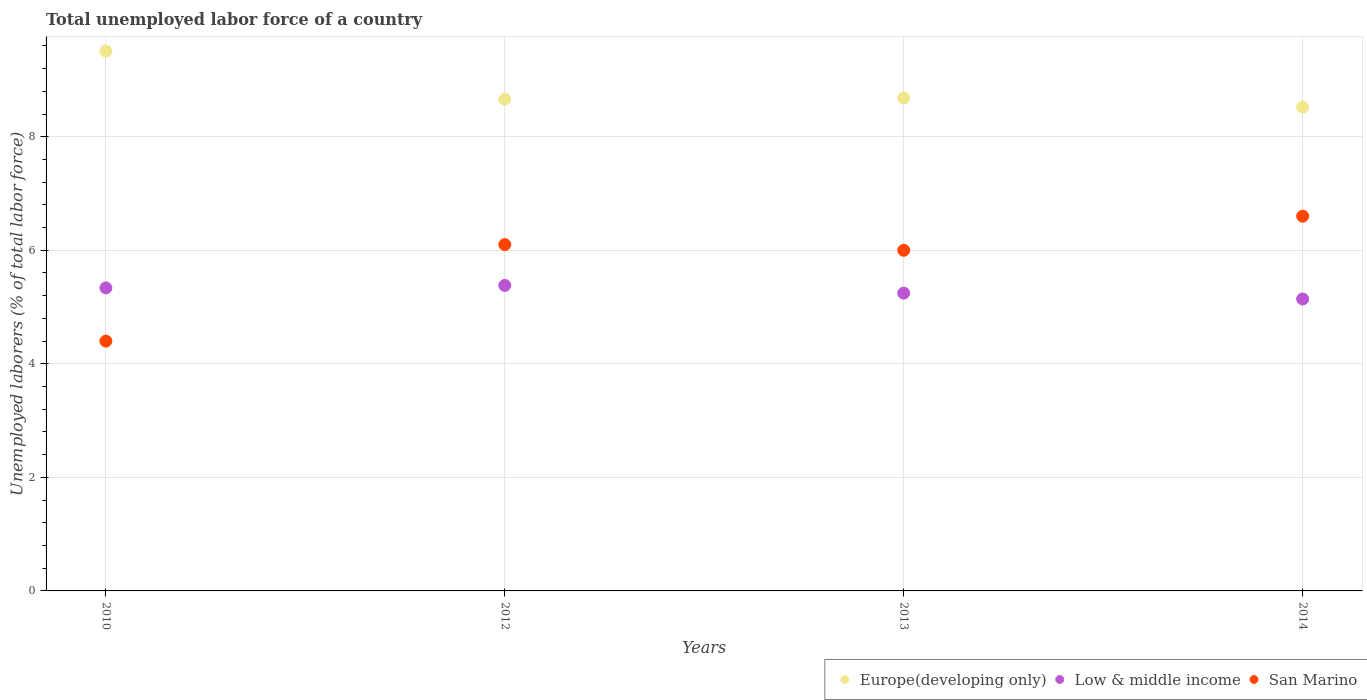Is the number of dotlines equal to the number of legend labels?
Offer a very short reply. Yes. What is the total unemployed labor force in San Marino in 2010?
Your response must be concise. 4.4. Across all years, what is the maximum total unemployed labor force in San Marino?
Offer a terse response. 6.6. Across all years, what is the minimum total unemployed labor force in Europe(developing only)?
Offer a terse response. 8.52. In which year was the total unemployed labor force in Europe(developing only) maximum?
Your answer should be compact. 2010. What is the total total unemployed labor force in San Marino in the graph?
Your answer should be very brief. 23.1. What is the difference between the total unemployed labor force in Low & middle income in 2012 and that in 2014?
Provide a short and direct response. 0.24. What is the difference between the total unemployed labor force in San Marino in 2014 and the total unemployed labor force in Europe(developing only) in 2010?
Your answer should be compact. -2.91. What is the average total unemployed labor force in Europe(developing only) per year?
Keep it short and to the point. 8.84. In the year 2014, what is the difference between the total unemployed labor force in Low & middle income and total unemployed labor force in Europe(developing only)?
Offer a terse response. -3.38. In how many years, is the total unemployed labor force in San Marino greater than 4.4 %?
Your response must be concise. 4. What is the ratio of the total unemployed labor force in Europe(developing only) in 2013 to that in 2014?
Keep it short and to the point. 1.02. What is the difference between the highest and the second highest total unemployed labor force in Low & middle income?
Provide a short and direct response. 0.04. What is the difference between the highest and the lowest total unemployed labor force in San Marino?
Your answer should be compact. 2.2. Is the sum of the total unemployed labor force in Low & middle income in 2012 and 2014 greater than the maximum total unemployed labor force in Europe(developing only) across all years?
Offer a terse response. Yes. Does the total unemployed labor force in Low & middle income monotonically increase over the years?
Your response must be concise. No. Is the total unemployed labor force in Low & middle income strictly greater than the total unemployed labor force in Europe(developing only) over the years?
Your answer should be compact. No. How many dotlines are there?
Make the answer very short. 3. How many years are there in the graph?
Offer a terse response. 4. Are the values on the major ticks of Y-axis written in scientific E-notation?
Offer a terse response. No. Where does the legend appear in the graph?
Keep it short and to the point. Bottom right. What is the title of the graph?
Make the answer very short. Total unemployed labor force of a country. Does "Malawi" appear as one of the legend labels in the graph?
Give a very brief answer. No. What is the label or title of the Y-axis?
Keep it short and to the point. Unemployed laborers (% of total labor force). What is the Unemployed laborers (% of total labor force) in Europe(developing only) in 2010?
Offer a terse response. 9.51. What is the Unemployed laborers (% of total labor force) in Low & middle income in 2010?
Provide a short and direct response. 5.34. What is the Unemployed laborers (% of total labor force) of San Marino in 2010?
Provide a short and direct response. 4.4. What is the Unemployed laborers (% of total labor force) in Europe(developing only) in 2012?
Ensure brevity in your answer.  8.66. What is the Unemployed laborers (% of total labor force) of Low & middle income in 2012?
Your answer should be very brief. 5.38. What is the Unemployed laborers (% of total labor force) of San Marino in 2012?
Offer a terse response. 6.1. What is the Unemployed laborers (% of total labor force) in Europe(developing only) in 2013?
Ensure brevity in your answer.  8.68. What is the Unemployed laborers (% of total labor force) in Low & middle income in 2013?
Your response must be concise. 5.24. What is the Unemployed laborers (% of total labor force) in Europe(developing only) in 2014?
Your answer should be very brief. 8.52. What is the Unemployed laborers (% of total labor force) in Low & middle income in 2014?
Give a very brief answer. 5.14. What is the Unemployed laborers (% of total labor force) of San Marino in 2014?
Offer a terse response. 6.6. Across all years, what is the maximum Unemployed laborers (% of total labor force) in Europe(developing only)?
Keep it short and to the point. 9.51. Across all years, what is the maximum Unemployed laborers (% of total labor force) of Low & middle income?
Your answer should be very brief. 5.38. Across all years, what is the maximum Unemployed laborers (% of total labor force) in San Marino?
Your answer should be very brief. 6.6. Across all years, what is the minimum Unemployed laborers (% of total labor force) of Europe(developing only)?
Give a very brief answer. 8.52. Across all years, what is the minimum Unemployed laborers (% of total labor force) of Low & middle income?
Give a very brief answer. 5.14. Across all years, what is the minimum Unemployed laborers (% of total labor force) in San Marino?
Your answer should be compact. 4.4. What is the total Unemployed laborers (% of total labor force) in Europe(developing only) in the graph?
Offer a very short reply. 35.37. What is the total Unemployed laborers (% of total labor force) of Low & middle income in the graph?
Your response must be concise. 21.1. What is the total Unemployed laborers (% of total labor force) in San Marino in the graph?
Make the answer very short. 23.1. What is the difference between the Unemployed laborers (% of total labor force) in Europe(developing only) in 2010 and that in 2012?
Keep it short and to the point. 0.85. What is the difference between the Unemployed laborers (% of total labor force) in Low & middle income in 2010 and that in 2012?
Make the answer very short. -0.04. What is the difference between the Unemployed laborers (% of total labor force) of San Marino in 2010 and that in 2012?
Provide a succinct answer. -1.7. What is the difference between the Unemployed laborers (% of total labor force) in Europe(developing only) in 2010 and that in 2013?
Offer a very short reply. 0.83. What is the difference between the Unemployed laborers (% of total labor force) of Low & middle income in 2010 and that in 2013?
Offer a terse response. 0.09. What is the difference between the Unemployed laborers (% of total labor force) in Europe(developing only) in 2010 and that in 2014?
Your answer should be very brief. 0.99. What is the difference between the Unemployed laborers (% of total labor force) in Low & middle income in 2010 and that in 2014?
Make the answer very short. 0.2. What is the difference between the Unemployed laborers (% of total labor force) of San Marino in 2010 and that in 2014?
Your response must be concise. -2.2. What is the difference between the Unemployed laborers (% of total labor force) of Europe(developing only) in 2012 and that in 2013?
Your answer should be compact. -0.02. What is the difference between the Unemployed laborers (% of total labor force) of Low & middle income in 2012 and that in 2013?
Offer a very short reply. 0.14. What is the difference between the Unemployed laborers (% of total labor force) in Europe(developing only) in 2012 and that in 2014?
Give a very brief answer. 0.14. What is the difference between the Unemployed laborers (% of total labor force) of Low & middle income in 2012 and that in 2014?
Provide a short and direct response. 0.24. What is the difference between the Unemployed laborers (% of total labor force) in San Marino in 2012 and that in 2014?
Your response must be concise. -0.5. What is the difference between the Unemployed laborers (% of total labor force) in Europe(developing only) in 2013 and that in 2014?
Keep it short and to the point. 0.16. What is the difference between the Unemployed laborers (% of total labor force) in Low & middle income in 2013 and that in 2014?
Keep it short and to the point. 0.1. What is the difference between the Unemployed laborers (% of total labor force) in San Marino in 2013 and that in 2014?
Offer a very short reply. -0.6. What is the difference between the Unemployed laborers (% of total labor force) in Europe(developing only) in 2010 and the Unemployed laborers (% of total labor force) in Low & middle income in 2012?
Your answer should be very brief. 4.13. What is the difference between the Unemployed laborers (% of total labor force) in Europe(developing only) in 2010 and the Unemployed laborers (% of total labor force) in San Marino in 2012?
Offer a terse response. 3.41. What is the difference between the Unemployed laborers (% of total labor force) in Low & middle income in 2010 and the Unemployed laborers (% of total labor force) in San Marino in 2012?
Keep it short and to the point. -0.76. What is the difference between the Unemployed laborers (% of total labor force) of Europe(developing only) in 2010 and the Unemployed laborers (% of total labor force) of Low & middle income in 2013?
Your response must be concise. 4.26. What is the difference between the Unemployed laborers (% of total labor force) of Europe(developing only) in 2010 and the Unemployed laborers (% of total labor force) of San Marino in 2013?
Provide a succinct answer. 3.51. What is the difference between the Unemployed laborers (% of total labor force) of Low & middle income in 2010 and the Unemployed laborers (% of total labor force) of San Marino in 2013?
Your answer should be compact. -0.66. What is the difference between the Unemployed laborers (% of total labor force) of Europe(developing only) in 2010 and the Unemployed laborers (% of total labor force) of Low & middle income in 2014?
Make the answer very short. 4.37. What is the difference between the Unemployed laborers (% of total labor force) in Europe(developing only) in 2010 and the Unemployed laborers (% of total labor force) in San Marino in 2014?
Your answer should be compact. 2.91. What is the difference between the Unemployed laborers (% of total labor force) of Low & middle income in 2010 and the Unemployed laborers (% of total labor force) of San Marino in 2014?
Your answer should be very brief. -1.26. What is the difference between the Unemployed laborers (% of total labor force) of Europe(developing only) in 2012 and the Unemployed laborers (% of total labor force) of Low & middle income in 2013?
Your response must be concise. 3.41. What is the difference between the Unemployed laborers (% of total labor force) in Europe(developing only) in 2012 and the Unemployed laborers (% of total labor force) in San Marino in 2013?
Ensure brevity in your answer.  2.66. What is the difference between the Unemployed laborers (% of total labor force) in Low & middle income in 2012 and the Unemployed laborers (% of total labor force) in San Marino in 2013?
Give a very brief answer. -0.62. What is the difference between the Unemployed laborers (% of total labor force) of Europe(developing only) in 2012 and the Unemployed laborers (% of total labor force) of Low & middle income in 2014?
Offer a very short reply. 3.52. What is the difference between the Unemployed laborers (% of total labor force) of Europe(developing only) in 2012 and the Unemployed laborers (% of total labor force) of San Marino in 2014?
Your answer should be very brief. 2.06. What is the difference between the Unemployed laborers (% of total labor force) in Low & middle income in 2012 and the Unemployed laborers (% of total labor force) in San Marino in 2014?
Ensure brevity in your answer.  -1.22. What is the difference between the Unemployed laborers (% of total labor force) in Europe(developing only) in 2013 and the Unemployed laborers (% of total labor force) in Low & middle income in 2014?
Keep it short and to the point. 3.54. What is the difference between the Unemployed laborers (% of total labor force) in Europe(developing only) in 2013 and the Unemployed laborers (% of total labor force) in San Marino in 2014?
Keep it short and to the point. 2.08. What is the difference between the Unemployed laborers (% of total labor force) of Low & middle income in 2013 and the Unemployed laborers (% of total labor force) of San Marino in 2014?
Keep it short and to the point. -1.35. What is the average Unemployed laborers (% of total labor force) of Europe(developing only) per year?
Your response must be concise. 8.84. What is the average Unemployed laborers (% of total labor force) in Low & middle income per year?
Make the answer very short. 5.28. What is the average Unemployed laborers (% of total labor force) in San Marino per year?
Your answer should be very brief. 5.78. In the year 2010, what is the difference between the Unemployed laborers (% of total labor force) of Europe(developing only) and Unemployed laborers (% of total labor force) of Low & middle income?
Ensure brevity in your answer.  4.17. In the year 2010, what is the difference between the Unemployed laborers (% of total labor force) in Europe(developing only) and Unemployed laborers (% of total labor force) in San Marino?
Ensure brevity in your answer.  5.11. In the year 2010, what is the difference between the Unemployed laborers (% of total labor force) in Low & middle income and Unemployed laborers (% of total labor force) in San Marino?
Make the answer very short. 0.94. In the year 2012, what is the difference between the Unemployed laborers (% of total labor force) of Europe(developing only) and Unemployed laborers (% of total labor force) of Low & middle income?
Ensure brevity in your answer.  3.28. In the year 2012, what is the difference between the Unemployed laborers (% of total labor force) in Europe(developing only) and Unemployed laborers (% of total labor force) in San Marino?
Make the answer very short. 2.56. In the year 2012, what is the difference between the Unemployed laborers (% of total labor force) of Low & middle income and Unemployed laborers (% of total labor force) of San Marino?
Keep it short and to the point. -0.72. In the year 2013, what is the difference between the Unemployed laborers (% of total labor force) in Europe(developing only) and Unemployed laborers (% of total labor force) in Low & middle income?
Keep it short and to the point. 3.44. In the year 2013, what is the difference between the Unemployed laborers (% of total labor force) of Europe(developing only) and Unemployed laborers (% of total labor force) of San Marino?
Ensure brevity in your answer.  2.68. In the year 2013, what is the difference between the Unemployed laborers (% of total labor force) of Low & middle income and Unemployed laborers (% of total labor force) of San Marino?
Ensure brevity in your answer.  -0.76. In the year 2014, what is the difference between the Unemployed laborers (% of total labor force) in Europe(developing only) and Unemployed laborers (% of total labor force) in Low & middle income?
Your response must be concise. 3.38. In the year 2014, what is the difference between the Unemployed laborers (% of total labor force) in Europe(developing only) and Unemployed laborers (% of total labor force) in San Marino?
Make the answer very short. 1.92. In the year 2014, what is the difference between the Unemployed laborers (% of total labor force) of Low & middle income and Unemployed laborers (% of total labor force) of San Marino?
Your response must be concise. -1.46. What is the ratio of the Unemployed laborers (% of total labor force) of Europe(developing only) in 2010 to that in 2012?
Keep it short and to the point. 1.1. What is the ratio of the Unemployed laborers (% of total labor force) of Low & middle income in 2010 to that in 2012?
Provide a succinct answer. 0.99. What is the ratio of the Unemployed laborers (% of total labor force) of San Marino in 2010 to that in 2012?
Give a very brief answer. 0.72. What is the ratio of the Unemployed laborers (% of total labor force) of Europe(developing only) in 2010 to that in 2013?
Ensure brevity in your answer.  1.1. What is the ratio of the Unemployed laborers (% of total labor force) in Low & middle income in 2010 to that in 2013?
Provide a short and direct response. 1.02. What is the ratio of the Unemployed laborers (% of total labor force) of San Marino in 2010 to that in 2013?
Provide a short and direct response. 0.73. What is the ratio of the Unemployed laborers (% of total labor force) in Europe(developing only) in 2010 to that in 2014?
Keep it short and to the point. 1.12. What is the ratio of the Unemployed laborers (% of total labor force) of Low & middle income in 2010 to that in 2014?
Your answer should be compact. 1.04. What is the ratio of the Unemployed laborers (% of total labor force) in San Marino in 2010 to that in 2014?
Make the answer very short. 0.67. What is the ratio of the Unemployed laborers (% of total labor force) in Low & middle income in 2012 to that in 2013?
Make the answer very short. 1.03. What is the ratio of the Unemployed laborers (% of total labor force) of San Marino in 2012 to that in 2013?
Your answer should be very brief. 1.02. What is the ratio of the Unemployed laborers (% of total labor force) of Europe(developing only) in 2012 to that in 2014?
Make the answer very short. 1.02. What is the ratio of the Unemployed laborers (% of total labor force) in Low & middle income in 2012 to that in 2014?
Make the answer very short. 1.05. What is the ratio of the Unemployed laborers (% of total labor force) in San Marino in 2012 to that in 2014?
Your answer should be very brief. 0.92. What is the ratio of the Unemployed laborers (% of total labor force) in Europe(developing only) in 2013 to that in 2014?
Your answer should be very brief. 1.02. What is the ratio of the Unemployed laborers (% of total labor force) in Low & middle income in 2013 to that in 2014?
Ensure brevity in your answer.  1.02. What is the difference between the highest and the second highest Unemployed laborers (% of total labor force) in Europe(developing only)?
Your answer should be very brief. 0.83. What is the difference between the highest and the second highest Unemployed laborers (% of total labor force) in Low & middle income?
Make the answer very short. 0.04. What is the difference between the highest and the second highest Unemployed laborers (% of total labor force) of San Marino?
Provide a succinct answer. 0.5. What is the difference between the highest and the lowest Unemployed laborers (% of total labor force) of Europe(developing only)?
Your answer should be compact. 0.99. What is the difference between the highest and the lowest Unemployed laborers (% of total labor force) of Low & middle income?
Your answer should be compact. 0.24. What is the difference between the highest and the lowest Unemployed laborers (% of total labor force) in San Marino?
Ensure brevity in your answer.  2.2. 